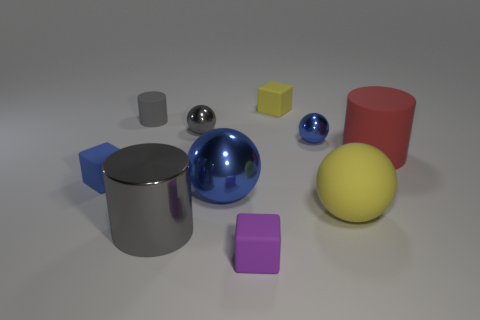Can you describe the lighting and mood of the image? The image is lit with soft, diffuse lighting that casts gentle shadows and gives the scene a calm, almost clinical atmosphere. There's no harsh or direct light visible, which results in a lack of strong contrast and maintains a serene mood, perfect for analyzing or showcasing the objects within the environment. 